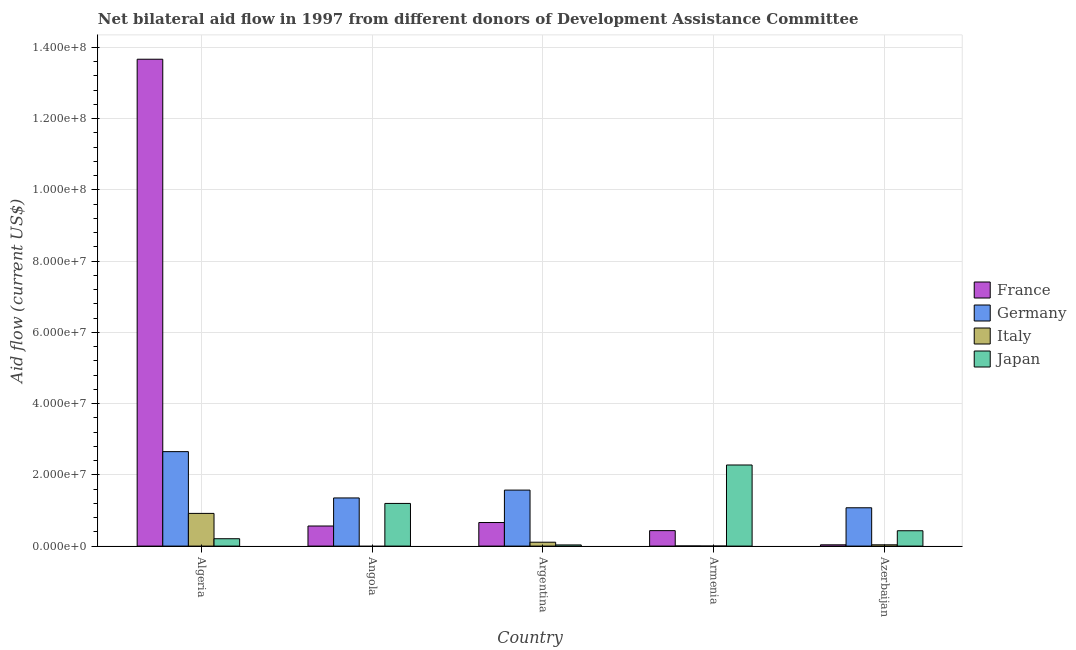How many different coloured bars are there?
Offer a terse response. 4. Are the number of bars per tick equal to the number of legend labels?
Provide a succinct answer. No. How many bars are there on the 2nd tick from the left?
Provide a short and direct response. 3. What is the label of the 3rd group of bars from the left?
Make the answer very short. Argentina. What is the amount of aid given by japan in Armenia?
Your answer should be very brief. 2.28e+07. Across all countries, what is the maximum amount of aid given by germany?
Offer a very short reply. 2.65e+07. Across all countries, what is the minimum amount of aid given by germany?
Your answer should be very brief. 4.00e+04. In which country was the amount of aid given by france maximum?
Provide a short and direct response. Algeria. What is the total amount of aid given by japan in the graph?
Give a very brief answer. 4.15e+07. What is the difference between the amount of aid given by germany in Angola and that in Armenia?
Your answer should be very brief. 1.35e+07. What is the difference between the amount of aid given by japan in Algeria and the amount of aid given by germany in Armenia?
Make the answer very short. 2.03e+06. What is the average amount of aid given by france per country?
Provide a succinct answer. 3.07e+07. What is the difference between the amount of aid given by germany and amount of aid given by france in Angola?
Offer a terse response. 7.88e+06. In how many countries, is the amount of aid given by italy greater than 48000000 US$?
Make the answer very short. 0. What is the ratio of the amount of aid given by germany in Algeria to that in Armenia?
Offer a terse response. 663. Is the amount of aid given by italy in Argentina less than that in Azerbaijan?
Ensure brevity in your answer.  No. Is the difference between the amount of aid given by germany in Algeria and Angola greater than the difference between the amount of aid given by france in Algeria and Angola?
Your answer should be very brief. No. What is the difference between the highest and the second highest amount of aid given by germany?
Your answer should be compact. 1.08e+07. What is the difference between the highest and the lowest amount of aid given by japan?
Provide a succinct answer. 2.24e+07. In how many countries, is the amount of aid given by france greater than the average amount of aid given by france taken over all countries?
Your answer should be very brief. 1. Is it the case that in every country, the sum of the amount of aid given by germany and amount of aid given by france is greater than the sum of amount of aid given by italy and amount of aid given by japan?
Provide a short and direct response. No. Is it the case that in every country, the sum of the amount of aid given by france and amount of aid given by germany is greater than the amount of aid given by italy?
Provide a succinct answer. Yes. Are the values on the major ticks of Y-axis written in scientific E-notation?
Offer a terse response. Yes. Does the graph contain any zero values?
Keep it short and to the point. Yes. Does the graph contain grids?
Make the answer very short. Yes. Where does the legend appear in the graph?
Ensure brevity in your answer.  Center right. How many legend labels are there?
Provide a succinct answer. 4. How are the legend labels stacked?
Provide a short and direct response. Vertical. What is the title of the graph?
Keep it short and to the point. Net bilateral aid flow in 1997 from different donors of Development Assistance Committee. Does "Third 20% of population" appear as one of the legend labels in the graph?
Offer a very short reply. No. What is the label or title of the X-axis?
Provide a succinct answer. Country. What is the label or title of the Y-axis?
Make the answer very short. Aid flow (current US$). What is the Aid flow (current US$) in France in Algeria?
Provide a succinct answer. 1.37e+08. What is the Aid flow (current US$) in Germany in Algeria?
Your answer should be very brief. 2.65e+07. What is the Aid flow (current US$) in Italy in Algeria?
Offer a terse response. 9.18e+06. What is the Aid flow (current US$) in Japan in Algeria?
Keep it short and to the point. 2.07e+06. What is the Aid flow (current US$) of France in Angola?
Give a very brief answer. 5.64e+06. What is the Aid flow (current US$) of Germany in Angola?
Make the answer very short. 1.35e+07. What is the Aid flow (current US$) in Italy in Angola?
Keep it short and to the point. 0. What is the Aid flow (current US$) in Japan in Angola?
Keep it short and to the point. 1.20e+07. What is the Aid flow (current US$) in France in Argentina?
Provide a short and direct response. 6.62e+06. What is the Aid flow (current US$) in Germany in Argentina?
Offer a terse response. 1.57e+07. What is the Aid flow (current US$) in Italy in Argentina?
Offer a terse response. 1.09e+06. What is the Aid flow (current US$) of France in Armenia?
Offer a very short reply. 4.34e+06. What is the Aid flow (current US$) of Germany in Armenia?
Ensure brevity in your answer.  4.00e+04. What is the Aid flow (current US$) of Japan in Armenia?
Keep it short and to the point. 2.28e+07. What is the Aid flow (current US$) of Germany in Azerbaijan?
Ensure brevity in your answer.  1.08e+07. What is the Aid flow (current US$) of Italy in Azerbaijan?
Your response must be concise. 3.60e+05. What is the Aid flow (current US$) in Japan in Azerbaijan?
Your response must be concise. 4.31e+06. Across all countries, what is the maximum Aid flow (current US$) in France?
Ensure brevity in your answer.  1.37e+08. Across all countries, what is the maximum Aid flow (current US$) of Germany?
Your answer should be very brief. 2.65e+07. Across all countries, what is the maximum Aid flow (current US$) of Italy?
Provide a short and direct response. 9.18e+06. Across all countries, what is the maximum Aid flow (current US$) in Japan?
Your answer should be very brief. 2.28e+07. Across all countries, what is the minimum Aid flow (current US$) in France?
Your response must be concise. 3.60e+05. Across all countries, what is the minimum Aid flow (current US$) of Germany?
Offer a terse response. 4.00e+04. Across all countries, what is the minimum Aid flow (current US$) of Italy?
Provide a short and direct response. 0. Across all countries, what is the minimum Aid flow (current US$) of Japan?
Provide a succinct answer. 3.30e+05. What is the total Aid flow (current US$) of France in the graph?
Your response must be concise. 1.54e+08. What is the total Aid flow (current US$) in Germany in the graph?
Give a very brief answer. 6.66e+07. What is the total Aid flow (current US$) of Italy in the graph?
Ensure brevity in your answer.  1.06e+07. What is the total Aid flow (current US$) in Japan in the graph?
Your answer should be very brief. 4.15e+07. What is the difference between the Aid flow (current US$) in France in Algeria and that in Angola?
Make the answer very short. 1.31e+08. What is the difference between the Aid flow (current US$) of Germany in Algeria and that in Angola?
Make the answer very short. 1.30e+07. What is the difference between the Aid flow (current US$) of Japan in Algeria and that in Angola?
Give a very brief answer. -9.91e+06. What is the difference between the Aid flow (current US$) of France in Algeria and that in Argentina?
Make the answer very short. 1.30e+08. What is the difference between the Aid flow (current US$) in Germany in Algeria and that in Argentina?
Offer a terse response. 1.08e+07. What is the difference between the Aid flow (current US$) in Italy in Algeria and that in Argentina?
Give a very brief answer. 8.09e+06. What is the difference between the Aid flow (current US$) of Japan in Algeria and that in Argentina?
Ensure brevity in your answer.  1.74e+06. What is the difference between the Aid flow (current US$) in France in Algeria and that in Armenia?
Offer a very short reply. 1.32e+08. What is the difference between the Aid flow (current US$) of Germany in Algeria and that in Armenia?
Provide a succinct answer. 2.65e+07. What is the difference between the Aid flow (current US$) of Italy in Algeria and that in Armenia?
Your response must be concise. 9.17e+06. What is the difference between the Aid flow (current US$) in Japan in Algeria and that in Armenia?
Offer a very short reply. -2.07e+07. What is the difference between the Aid flow (current US$) in France in Algeria and that in Azerbaijan?
Ensure brevity in your answer.  1.36e+08. What is the difference between the Aid flow (current US$) in Germany in Algeria and that in Azerbaijan?
Ensure brevity in your answer.  1.58e+07. What is the difference between the Aid flow (current US$) of Italy in Algeria and that in Azerbaijan?
Offer a terse response. 8.82e+06. What is the difference between the Aid flow (current US$) of Japan in Algeria and that in Azerbaijan?
Offer a very short reply. -2.24e+06. What is the difference between the Aid flow (current US$) in France in Angola and that in Argentina?
Offer a very short reply. -9.80e+05. What is the difference between the Aid flow (current US$) of Germany in Angola and that in Argentina?
Your answer should be very brief. -2.20e+06. What is the difference between the Aid flow (current US$) of Japan in Angola and that in Argentina?
Give a very brief answer. 1.16e+07. What is the difference between the Aid flow (current US$) in France in Angola and that in Armenia?
Keep it short and to the point. 1.30e+06. What is the difference between the Aid flow (current US$) in Germany in Angola and that in Armenia?
Provide a succinct answer. 1.35e+07. What is the difference between the Aid flow (current US$) in Japan in Angola and that in Armenia?
Your answer should be compact. -1.08e+07. What is the difference between the Aid flow (current US$) in France in Angola and that in Azerbaijan?
Provide a short and direct response. 5.28e+06. What is the difference between the Aid flow (current US$) of Germany in Angola and that in Azerbaijan?
Provide a short and direct response. 2.76e+06. What is the difference between the Aid flow (current US$) in Japan in Angola and that in Azerbaijan?
Your answer should be very brief. 7.67e+06. What is the difference between the Aid flow (current US$) of France in Argentina and that in Armenia?
Make the answer very short. 2.28e+06. What is the difference between the Aid flow (current US$) in Germany in Argentina and that in Armenia?
Your response must be concise. 1.57e+07. What is the difference between the Aid flow (current US$) of Italy in Argentina and that in Armenia?
Offer a very short reply. 1.08e+06. What is the difference between the Aid flow (current US$) of Japan in Argentina and that in Armenia?
Offer a terse response. -2.24e+07. What is the difference between the Aid flow (current US$) in France in Argentina and that in Azerbaijan?
Your response must be concise. 6.26e+06. What is the difference between the Aid flow (current US$) in Germany in Argentina and that in Azerbaijan?
Make the answer very short. 4.96e+06. What is the difference between the Aid flow (current US$) of Italy in Argentina and that in Azerbaijan?
Your answer should be compact. 7.30e+05. What is the difference between the Aid flow (current US$) of Japan in Argentina and that in Azerbaijan?
Provide a short and direct response. -3.98e+06. What is the difference between the Aid flow (current US$) in France in Armenia and that in Azerbaijan?
Make the answer very short. 3.98e+06. What is the difference between the Aid flow (current US$) in Germany in Armenia and that in Azerbaijan?
Offer a very short reply. -1.07e+07. What is the difference between the Aid flow (current US$) in Italy in Armenia and that in Azerbaijan?
Provide a succinct answer. -3.50e+05. What is the difference between the Aid flow (current US$) of Japan in Armenia and that in Azerbaijan?
Your answer should be very brief. 1.85e+07. What is the difference between the Aid flow (current US$) of France in Algeria and the Aid flow (current US$) of Germany in Angola?
Offer a terse response. 1.23e+08. What is the difference between the Aid flow (current US$) in France in Algeria and the Aid flow (current US$) in Japan in Angola?
Provide a short and direct response. 1.25e+08. What is the difference between the Aid flow (current US$) of Germany in Algeria and the Aid flow (current US$) of Japan in Angola?
Keep it short and to the point. 1.45e+07. What is the difference between the Aid flow (current US$) in Italy in Algeria and the Aid flow (current US$) in Japan in Angola?
Ensure brevity in your answer.  -2.80e+06. What is the difference between the Aid flow (current US$) of France in Algeria and the Aid flow (current US$) of Germany in Argentina?
Your answer should be very brief. 1.21e+08. What is the difference between the Aid flow (current US$) of France in Algeria and the Aid flow (current US$) of Italy in Argentina?
Ensure brevity in your answer.  1.36e+08. What is the difference between the Aid flow (current US$) of France in Algeria and the Aid flow (current US$) of Japan in Argentina?
Your response must be concise. 1.36e+08. What is the difference between the Aid flow (current US$) in Germany in Algeria and the Aid flow (current US$) in Italy in Argentina?
Provide a short and direct response. 2.54e+07. What is the difference between the Aid flow (current US$) of Germany in Algeria and the Aid flow (current US$) of Japan in Argentina?
Your response must be concise. 2.62e+07. What is the difference between the Aid flow (current US$) of Italy in Algeria and the Aid flow (current US$) of Japan in Argentina?
Provide a succinct answer. 8.85e+06. What is the difference between the Aid flow (current US$) in France in Algeria and the Aid flow (current US$) in Germany in Armenia?
Make the answer very short. 1.37e+08. What is the difference between the Aid flow (current US$) of France in Algeria and the Aid flow (current US$) of Italy in Armenia?
Provide a succinct answer. 1.37e+08. What is the difference between the Aid flow (current US$) in France in Algeria and the Aid flow (current US$) in Japan in Armenia?
Provide a succinct answer. 1.14e+08. What is the difference between the Aid flow (current US$) in Germany in Algeria and the Aid flow (current US$) in Italy in Armenia?
Give a very brief answer. 2.65e+07. What is the difference between the Aid flow (current US$) of Germany in Algeria and the Aid flow (current US$) of Japan in Armenia?
Provide a succinct answer. 3.75e+06. What is the difference between the Aid flow (current US$) in Italy in Algeria and the Aid flow (current US$) in Japan in Armenia?
Give a very brief answer. -1.36e+07. What is the difference between the Aid flow (current US$) in France in Algeria and the Aid flow (current US$) in Germany in Azerbaijan?
Make the answer very short. 1.26e+08. What is the difference between the Aid flow (current US$) in France in Algeria and the Aid flow (current US$) in Italy in Azerbaijan?
Your answer should be compact. 1.36e+08. What is the difference between the Aid flow (current US$) of France in Algeria and the Aid flow (current US$) of Japan in Azerbaijan?
Give a very brief answer. 1.32e+08. What is the difference between the Aid flow (current US$) in Germany in Algeria and the Aid flow (current US$) in Italy in Azerbaijan?
Provide a succinct answer. 2.62e+07. What is the difference between the Aid flow (current US$) in Germany in Algeria and the Aid flow (current US$) in Japan in Azerbaijan?
Keep it short and to the point. 2.22e+07. What is the difference between the Aid flow (current US$) of Italy in Algeria and the Aid flow (current US$) of Japan in Azerbaijan?
Your answer should be compact. 4.87e+06. What is the difference between the Aid flow (current US$) in France in Angola and the Aid flow (current US$) in Germany in Argentina?
Provide a short and direct response. -1.01e+07. What is the difference between the Aid flow (current US$) of France in Angola and the Aid flow (current US$) of Italy in Argentina?
Offer a very short reply. 4.55e+06. What is the difference between the Aid flow (current US$) of France in Angola and the Aid flow (current US$) of Japan in Argentina?
Give a very brief answer. 5.31e+06. What is the difference between the Aid flow (current US$) of Germany in Angola and the Aid flow (current US$) of Italy in Argentina?
Your answer should be very brief. 1.24e+07. What is the difference between the Aid flow (current US$) in Germany in Angola and the Aid flow (current US$) in Japan in Argentina?
Keep it short and to the point. 1.32e+07. What is the difference between the Aid flow (current US$) of France in Angola and the Aid flow (current US$) of Germany in Armenia?
Provide a succinct answer. 5.60e+06. What is the difference between the Aid flow (current US$) of France in Angola and the Aid flow (current US$) of Italy in Armenia?
Provide a succinct answer. 5.63e+06. What is the difference between the Aid flow (current US$) of France in Angola and the Aid flow (current US$) of Japan in Armenia?
Your answer should be very brief. -1.71e+07. What is the difference between the Aid flow (current US$) in Germany in Angola and the Aid flow (current US$) in Italy in Armenia?
Your answer should be compact. 1.35e+07. What is the difference between the Aid flow (current US$) in Germany in Angola and the Aid flow (current US$) in Japan in Armenia?
Provide a short and direct response. -9.25e+06. What is the difference between the Aid flow (current US$) of France in Angola and the Aid flow (current US$) of Germany in Azerbaijan?
Your answer should be very brief. -5.12e+06. What is the difference between the Aid flow (current US$) in France in Angola and the Aid flow (current US$) in Italy in Azerbaijan?
Keep it short and to the point. 5.28e+06. What is the difference between the Aid flow (current US$) of France in Angola and the Aid flow (current US$) of Japan in Azerbaijan?
Make the answer very short. 1.33e+06. What is the difference between the Aid flow (current US$) of Germany in Angola and the Aid flow (current US$) of Italy in Azerbaijan?
Your answer should be compact. 1.32e+07. What is the difference between the Aid flow (current US$) of Germany in Angola and the Aid flow (current US$) of Japan in Azerbaijan?
Give a very brief answer. 9.21e+06. What is the difference between the Aid flow (current US$) of France in Argentina and the Aid flow (current US$) of Germany in Armenia?
Make the answer very short. 6.58e+06. What is the difference between the Aid flow (current US$) of France in Argentina and the Aid flow (current US$) of Italy in Armenia?
Provide a short and direct response. 6.61e+06. What is the difference between the Aid flow (current US$) in France in Argentina and the Aid flow (current US$) in Japan in Armenia?
Your answer should be very brief. -1.62e+07. What is the difference between the Aid flow (current US$) in Germany in Argentina and the Aid flow (current US$) in Italy in Armenia?
Give a very brief answer. 1.57e+07. What is the difference between the Aid flow (current US$) in Germany in Argentina and the Aid flow (current US$) in Japan in Armenia?
Your response must be concise. -7.05e+06. What is the difference between the Aid flow (current US$) in Italy in Argentina and the Aid flow (current US$) in Japan in Armenia?
Offer a terse response. -2.17e+07. What is the difference between the Aid flow (current US$) in France in Argentina and the Aid flow (current US$) in Germany in Azerbaijan?
Offer a terse response. -4.14e+06. What is the difference between the Aid flow (current US$) of France in Argentina and the Aid flow (current US$) of Italy in Azerbaijan?
Ensure brevity in your answer.  6.26e+06. What is the difference between the Aid flow (current US$) in France in Argentina and the Aid flow (current US$) in Japan in Azerbaijan?
Your answer should be very brief. 2.31e+06. What is the difference between the Aid flow (current US$) of Germany in Argentina and the Aid flow (current US$) of Italy in Azerbaijan?
Offer a terse response. 1.54e+07. What is the difference between the Aid flow (current US$) of Germany in Argentina and the Aid flow (current US$) of Japan in Azerbaijan?
Your answer should be compact. 1.14e+07. What is the difference between the Aid flow (current US$) of Italy in Argentina and the Aid flow (current US$) of Japan in Azerbaijan?
Your answer should be compact. -3.22e+06. What is the difference between the Aid flow (current US$) in France in Armenia and the Aid flow (current US$) in Germany in Azerbaijan?
Offer a terse response. -6.42e+06. What is the difference between the Aid flow (current US$) of France in Armenia and the Aid flow (current US$) of Italy in Azerbaijan?
Make the answer very short. 3.98e+06. What is the difference between the Aid flow (current US$) in France in Armenia and the Aid flow (current US$) in Japan in Azerbaijan?
Keep it short and to the point. 3.00e+04. What is the difference between the Aid flow (current US$) of Germany in Armenia and the Aid flow (current US$) of Italy in Azerbaijan?
Give a very brief answer. -3.20e+05. What is the difference between the Aid flow (current US$) of Germany in Armenia and the Aid flow (current US$) of Japan in Azerbaijan?
Your response must be concise. -4.27e+06. What is the difference between the Aid flow (current US$) in Italy in Armenia and the Aid flow (current US$) in Japan in Azerbaijan?
Your answer should be compact. -4.30e+06. What is the average Aid flow (current US$) of France per country?
Provide a short and direct response. 3.07e+07. What is the average Aid flow (current US$) of Germany per country?
Make the answer very short. 1.33e+07. What is the average Aid flow (current US$) of Italy per country?
Ensure brevity in your answer.  2.13e+06. What is the average Aid flow (current US$) in Japan per country?
Give a very brief answer. 8.29e+06. What is the difference between the Aid flow (current US$) of France and Aid flow (current US$) of Germany in Algeria?
Give a very brief answer. 1.10e+08. What is the difference between the Aid flow (current US$) of France and Aid flow (current US$) of Italy in Algeria?
Make the answer very short. 1.28e+08. What is the difference between the Aid flow (current US$) in France and Aid flow (current US$) in Japan in Algeria?
Your answer should be compact. 1.35e+08. What is the difference between the Aid flow (current US$) of Germany and Aid flow (current US$) of Italy in Algeria?
Your response must be concise. 1.73e+07. What is the difference between the Aid flow (current US$) of Germany and Aid flow (current US$) of Japan in Algeria?
Your answer should be very brief. 2.44e+07. What is the difference between the Aid flow (current US$) in Italy and Aid flow (current US$) in Japan in Algeria?
Offer a very short reply. 7.11e+06. What is the difference between the Aid flow (current US$) of France and Aid flow (current US$) of Germany in Angola?
Your answer should be compact. -7.88e+06. What is the difference between the Aid flow (current US$) in France and Aid flow (current US$) in Japan in Angola?
Ensure brevity in your answer.  -6.34e+06. What is the difference between the Aid flow (current US$) in Germany and Aid flow (current US$) in Japan in Angola?
Make the answer very short. 1.54e+06. What is the difference between the Aid flow (current US$) in France and Aid flow (current US$) in Germany in Argentina?
Your answer should be compact. -9.10e+06. What is the difference between the Aid flow (current US$) of France and Aid flow (current US$) of Italy in Argentina?
Provide a succinct answer. 5.53e+06. What is the difference between the Aid flow (current US$) of France and Aid flow (current US$) of Japan in Argentina?
Your answer should be compact. 6.29e+06. What is the difference between the Aid flow (current US$) of Germany and Aid flow (current US$) of Italy in Argentina?
Give a very brief answer. 1.46e+07. What is the difference between the Aid flow (current US$) in Germany and Aid flow (current US$) in Japan in Argentina?
Keep it short and to the point. 1.54e+07. What is the difference between the Aid flow (current US$) of Italy and Aid flow (current US$) of Japan in Argentina?
Provide a short and direct response. 7.60e+05. What is the difference between the Aid flow (current US$) in France and Aid flow (current US$) in Germany in Armenia?
Your response must be concise. 4.30e+06. What is the difference between the Aid flow (current US$) of France and Aid flow (current US$) of Italy in Armenia?
Offer a very short reply. 4.33e+06. What is the difference between the Aid flow (current US$) in France and Aid flow (current US$) in Japan in Armenia?
Give a very brief answer. -1.84e+07. What is the difference between the Aid flow (current US$) of Germany and Aid flow (current US$) of Italy in Armenia?
Ensure brevity in your answer.  3.00e+04. What is the difference between the Aid flow (current US$) in Germany and Aid flow (current US$) in Japan in Armenia?
Make the answer very short. -2.27e+07. What is the difference between the Aid flow (current US$) in Italy and Aid flow (current US$) in Japan in Armenia?
Keep it short and to the point. -2.28e+07. What is the difference between the Aid flow (current US$) of France and Aid flow (current US$) of Germany in Azerbaijan?
Your response must be concise. -1.04e+07. What is the difference between the Aid flow (current US$) in France and Aid flow (current US$) in Japan in Azerbaijan?
Give a very brief answer. -3.95e+06. What is the difference between the Aid flow (current US$) of Germany and Aid flow (current US$) of Italy in Azerbaijan?
Keep it short and to the point. 1.04e+07. What is the difference between the Aid flow (current US$) in Germany and Aid flow (current US$) in Japan in Azerbaijan?
Offer a terse response. 6.45e+06. What is the difference between the Aid flow (current US$) of Italy and Aid flow (current US$) of Japan in Azerbaijan?
Your answer should be very brief. -3.95e+06. What is the ratio of the Aid flow (current US$) of France in Algeria to that in Angola?
Make the answer very short. 24.24. What is the ratio of the Aid flow (current US$) of Germany in Algeria to that in Angola?
Ensure brevity in your answer.  1.96. What is the ratio of the Aid flow (current US$) of Japan in Algeria to that in Angola?
Provide a succinct answer. 0.17. What is the ratio of the Aid flow (current US$) of France in Algeria to that in Argentina?
Offer a terse response. 20.65. What is the ratio of the Aid flow (current US$) of Germany in Algeria to that in Argentina?
Give a very brief answer. 1.69. What is the ratio of the Aid flow (current US$) of Italy in Algeria to that in Argentina?
Offer a very short reply. 8.42. What is the ratio of the Aid flow (current US$) in Japan in Algeria to that in Argentina?
Give a very brief answer. 6.27. What is the ratio of the Aid flow (current US$) in France in Algeria to that in Armenia?
Make the answer very short. 31.5. What is the ratio of the Aid flow (current US$) of Germany in Algeria to that in Armenia?
Your response must be concise. 663. What is the ratio of the Aid flow (current US$) in Italy in Algeria to that in Armenia?
Your response must be concise. 918. What is the ratio of the Aid flow (current US$) in Japan in Algeria to that in Armenia?
Provide a short and direct response. 0.09. What is the ratio of the Aid flow (current US$) in France in Algeria to that in Azerbaijan?
Provide a succinct answer. 379.69. What is the ratio of the Aid flow (current US$) of Germany in Algeria to that in Azerbaijan?
Your answer should be compact. 2.46. What is the ratio of the Aid flow (current US$) in Italy in Algeria to that in Azerbaijan?
Your response must be concise. 25.5. What is the ratio of the Aid flow (current US$) of Japan in Algeria to that in Azerbaijan?
Keep it short and to the point. 0.48. What is the ratio of the Aid flow (current US$) in France in Angola to that in Argentina?
Provide a succinct answer. 0.85. What is the ratio of the Aid flow (current US$) in Germany in Angola to that in Argentina?
Offer a very short reply. 0.86. What is the ratio of the Aid flow (current US$) in Japan in Angola to that in Argentina?
Provide a short and direct response. 36.3. What is the ratio of the Aid flow (current US$) of France in Angola to that in Armenia?
Your answer should be compact. 1.3. What is the ratio of the Aid flow (current US$) in Germany in Angola to that in Armenia?
Make the answer very short. 338. What is the ratio of the Aid flow (current US$) in Japan in Angola to that in Armenia?
Keep it short and to the point. 0.53. What is the ratio of the Aid flow (current US$) in France in Angola to that in Azerbaijan?
Provide a short and direct response. 15.67. What is the ratio of the Aid flow (current US$) of Germany in Angola to that in Azerbaijan?
Your answer should be very brief. 1.26. What is the ratio of the Aid flow (current US$) in Japan in Angola to that in Azerbaijan?
Ensure brevity in your answer.  2.78. What is the ratio of the Aid flow (current US$) in France in Argentina to that in Armenia?
Give a very brief answer. 1.53. What is the ratio of the Aid flow (current US$) in Germany in Argentina to that in Armenia?
Ensure brevity in your answer.  393. What is the ratio of the Aid flow (current US$) of Italy in Argentina to that in Armenia?
Give a very brief answer. 109. What is the ratio of the Aid flow (current US$) of Japan in Argentina to that in Armenia?
Your answer should be compact. 0.01. What is the ratio of the Aid flow (current US$) in France in Argentina to that in Azerbaijan?
Make the answer very short. 18.39. What is the ratio of the Aid flow (current US$) in Germany in Argentina to that in Azerbaijan?
Give a very brief answer. 1.46. What is the ratio of the Aid flow (current US$) in Italy in Argentina to that in Azerbaijan?
Give a very brief answer. 3.03. What is the ratio of the Aid flow (current US$) of Japan in Argentina to that in Azerbaijan?
Provide a short and direct response. 0.08. What is the ratio of the Aid flow (current US$) in France in Armenia to that in Azerbaijan?
Give a very brief answer. 12.06. What is the ratio of the Aid flow (current US$) in Germany in Armenia to that in Azerbaijan?
Ensure brevity in your answer.  0. What is the ratio of the Aid flow (current US$) in Italy in Armenia to that in Azerbaijan?
Make the answer very short. 0.03. What is the ratio of the Aid flow (current US$) in Japan in Armenia to that in Azerbaijan?
Ensure brevity in your answer.  5.28. What is the difference between the highest and the second highest Aid flow (current US$) in France?
Make the answer very short. 1.30e+08. What is the difference between the highest and the second highest Aid flow (current US$) of Germany?
Make the answer very short. 1.08e+07. What is the difference between the highest and the second highest Aid flow (current US$) in Italy?
Give a very brief answer. 8.09e+06. What is the difference between the highest and the second highest Aid flow (current US$) in Japan?
Your answer should be very brief. 1.08e+07. What is the difference between the highest and the lowest Aid flow (current US$) of France?
Make the answer very short. 1.36e+08. What is the difference between the highest and the lowest Aid flow (current US$) of Germany?
Provide a succinct answer. 2.65e+07. What is the difference between the highest and the lowest Aid flow (current US$) of Italy?
Provide a short and direct response. 9.18e+06. What is the difference between the highest and the lowest Aid flow (current US$) in Japan?
Provide a succinct answer. 2.24e+07. 